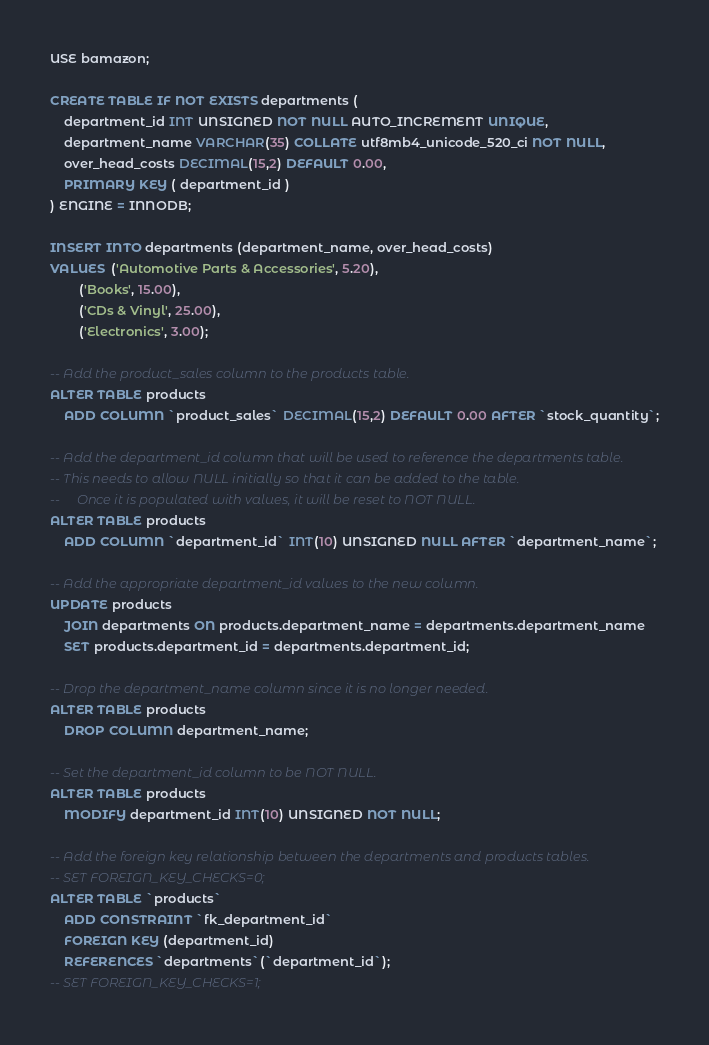<code> <loc_0><loc_0><loc_500><loc_500><_SQL_>USE bamazon;

CREATE TABLE IF NOT EXISTS departments (
    department_id INT UNSIGNED NOT NULL AUTO_INCREMENT UNIQUE,
    department_name VARCHAR(35) COLLATE utf8mb4_unicode_520_ci NOT NULL,
    over_head_costs DECIMAL(15,2) DEFAULT 0.00,
    PRIMARY KEY ( department_id )
) ENGINE = INNODB;

INSERT INTO departments (department_name, over_head_costs)
VALUES  ('Automotive Parts & Accessories', 5.20),
        ('Books', 15.00),
        ('CDs & Vinyl', 25.00),
        ('Electronics', 3.00);

-- Add the product_sales column to the products table.
ALTER TABLE products
    ADD COLUMN `product_sales` DECIMAL(15,2) DEFAULT 0.00 AFTER `stock_quantity`;

-- Add the department_id column that will be used to reference the departments table.
-- This needs to allow NULL initially so that it can be added to the table.
--     Once it is populated with values, it will be reset to NOT NULL.
ALTER TABLE products
    ADD COLUMN `department_id` INT(10) UNSIGNED NULL AFTER `department_name`;

-- Add the appropriate department_id values to the new column.
UPDATE products
    JOIN departments ON products.department_name = departments.department_name
    SET products.department_id = departments.department_id;

-- Drop the department_name column since it is no longer needed.
ALTER TABLE products
    DROP COLUMN department_name;

-- Set the department_id column to be NOT NULL.
ALTER TABLE products
    MODIFY department_id INT(10) UNSIGNED NOT NULL;

-- Add the foreign key relationship between the departments and products tables.
-- SET FOREIGN_KEY_CHECKS=0;
ALTER TABLE `products`
    ADD CONSTRAINT `fk_department_id`
    FOREIGN KEY (department_id)
    REFERENCES `departments`(`department_id`);
-- SET FOREIGN_KEY_CHECKS=1;
</code> 